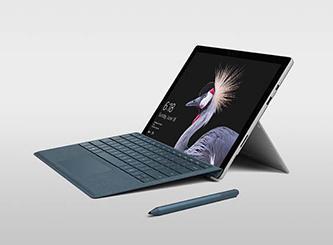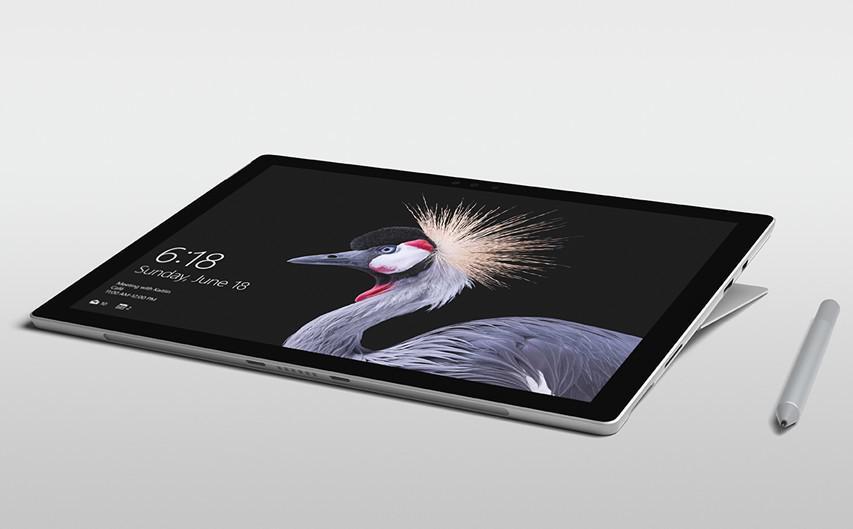The first image is the image on the left, the second image is the image on the right. Analyze the images presented: Is the assertion "There are no more than 2 stylus's sitting next to laptops." valid? Answer yes or no. Yes. The first image is the image on the left, the second image is the image on the right. For the images displayed, is the sentence "there is a stylus on the table next to a laptop" factually correct? Answer yes or no. Yes. 